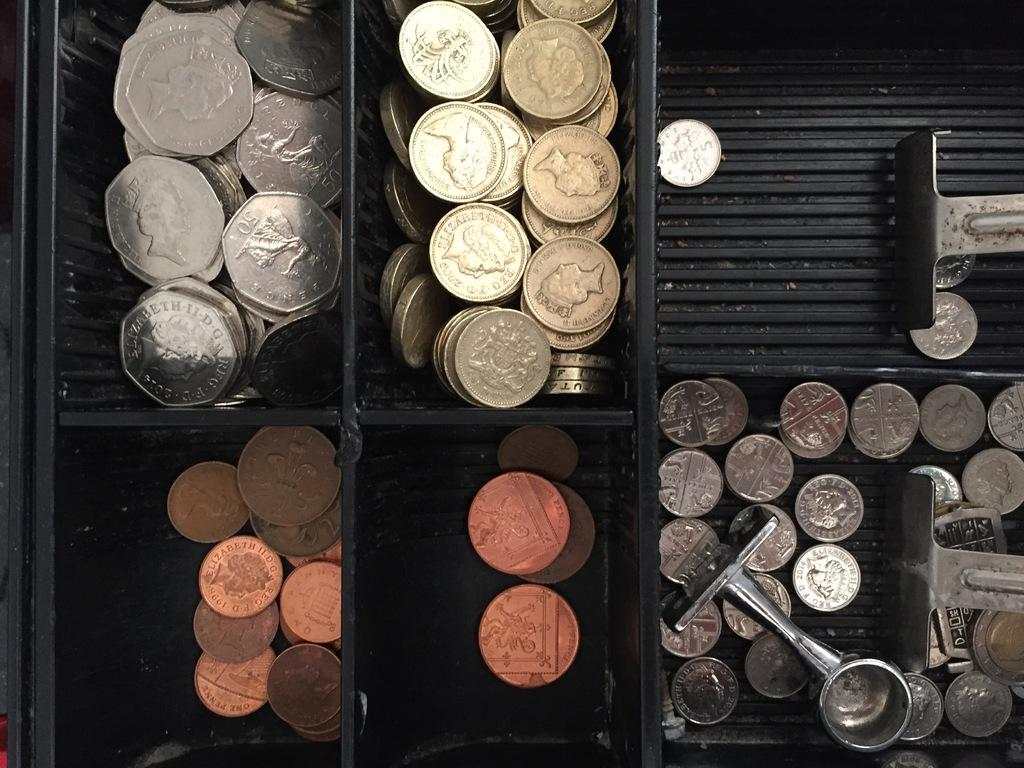<image>
Describe the image concisely. Elizabeth 2008 and 2014 are stamped onto the large coins. 